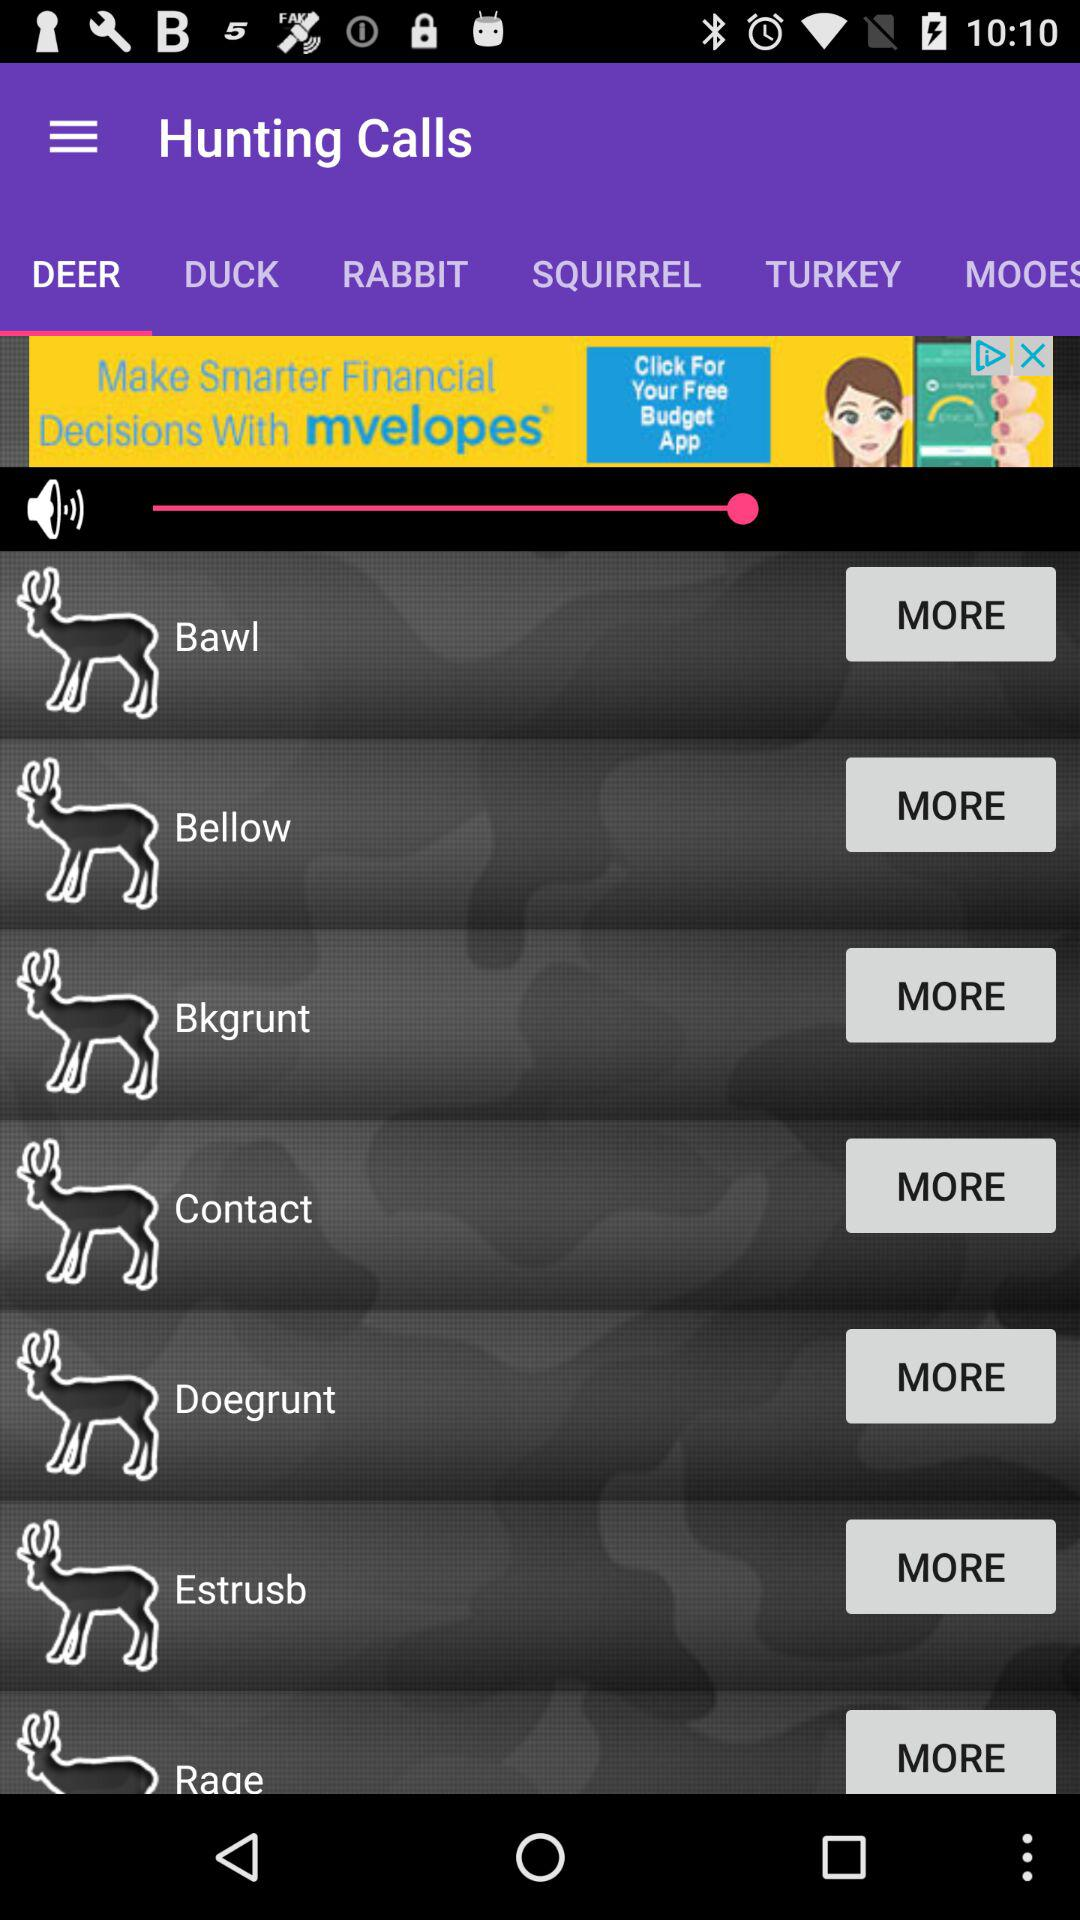Which tab am I on? You are on the "DEER" tab. 